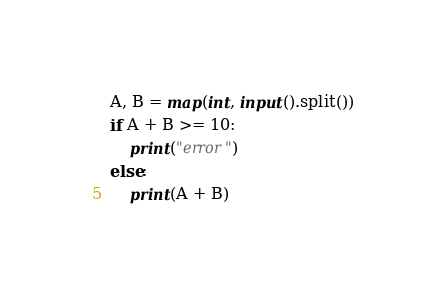Convert code to text. <code><loc_0><loc_0><loc_500><loc_500><_Python_>A, B = map(int, input().split())
if A + B >= 10:
    print("error")
else:
    print(A + B)
</code> 